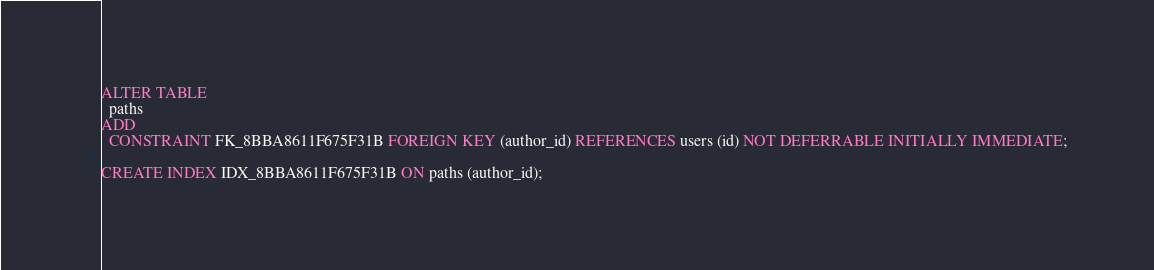Convert code to text. <code><loc_0><loc_0><loc_500><loc_500><_SQL_>ALTER TABLE
  paths
ADD
  CONSTRAINT FK_8BBA8611F675F31B FOREIGN KEY (author_id) REFERENCES users (id) NOT DEFERRABLE INITIALLY IMMEDIATE;

CREATE INDEX IDX_8BBA8611F675F31B ON paths (author_id);
</code> 